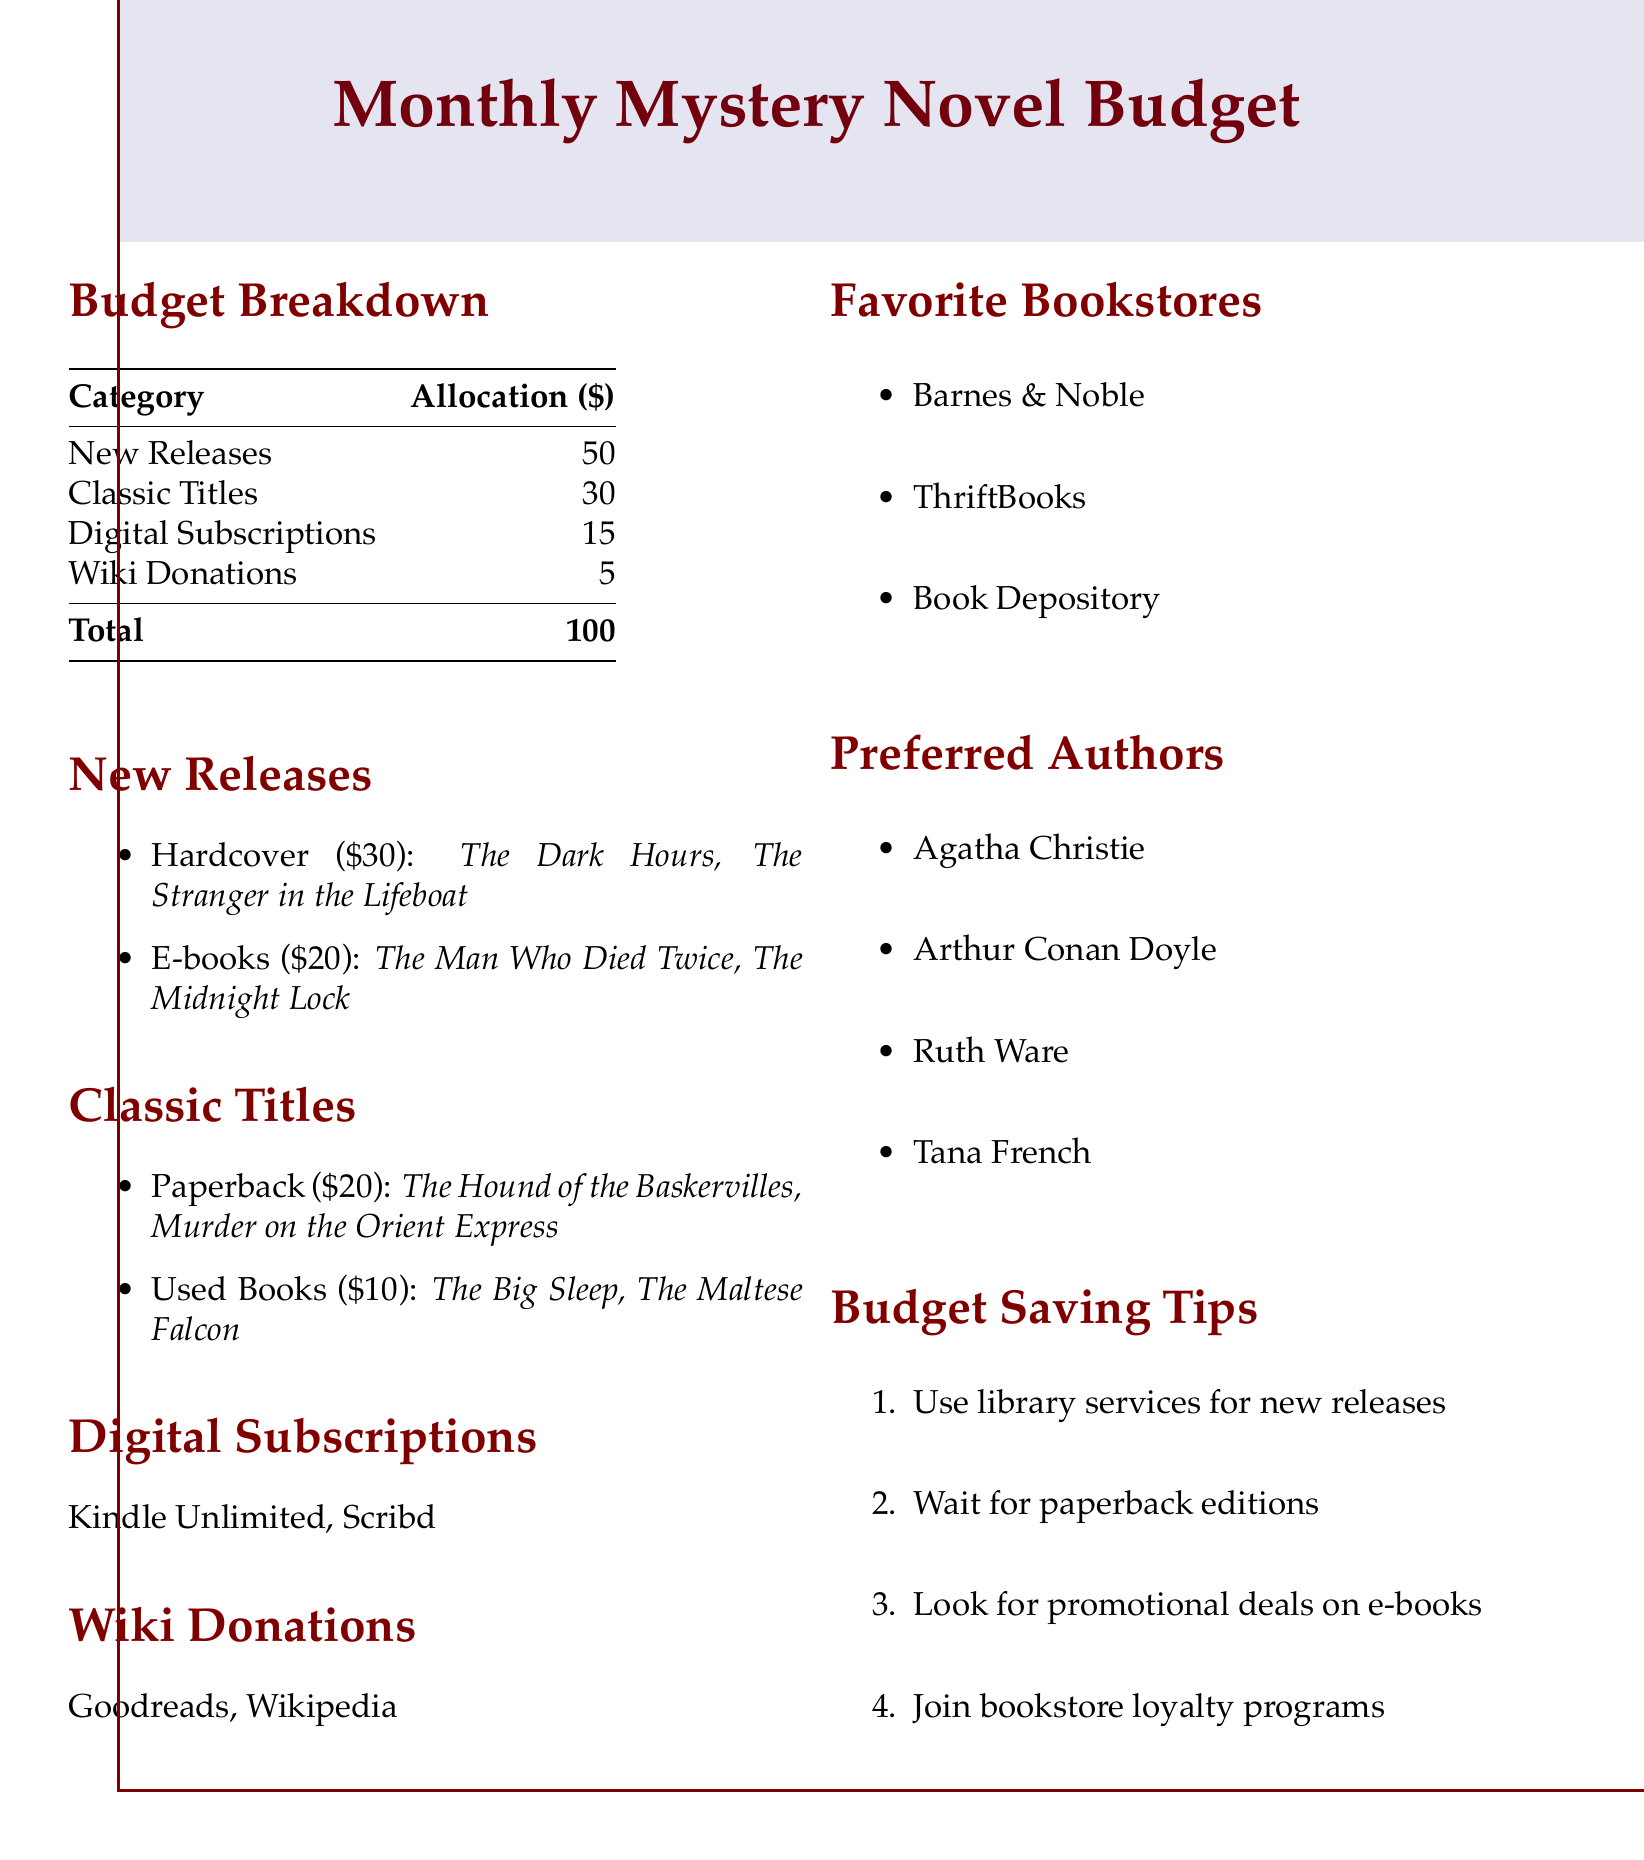What is the total monthly budget? The total monthly budget is found in the budget breakdown section of the document, totaling $100.
Answer: $100 How much is allocated for new releases? The allocation for new releases is specified in the budget breakdown, which indicates $50.
Answer: $50 What are two classic titles listed? The classic titles are found in their respective section, with two examples being "The Hound of the Baskervilles" and "Murder on the Orient Express."
Answer: The Hound of the Baskervilles, Murder on the Orient Express What is the cost of a hardcover new release? The cost of a hardcover new release is identified in the new releases section, which is $30.
Answer: $30 Which digital subscription services are mentioned? The document lists the digital subscription services in their dedicated section, naming Kindle Unlimited and Scribd.
Answer: Kindle Unlimited, Scribd What percentage of the budget is allocated for classic titles? By dividing the classic titles allocation by the total budget and converting to a percentage, the allocation is 30%.
Answer: 30% Name one favorite bookstore. The favorite bookstores are listed, with "Barnes & Noble" as one of them.
Answer: Barnes & Noble How much is budgeted for wiki donations? The budget allocated for wiki donations is specifically indicated as $5 in the breakdown.
Answer: $5 What is one budget saving tip mentioned? The budget saving tips are listed, with one example being to use library services for new releases.
Answer: Use library services for new releases 